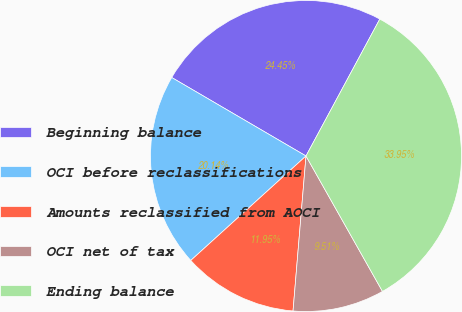<chart> <loc_0><loc_0><loc_500><loc_500><pie_chart><fcel>Beginning balance<fcel>OCI before reclassifications<fcel>Amounts reclassified from AOCI<fcel>OCI net of tax<fcel>Ending balance<nl><fcel>24.45%<fcel>20.14%<fcel>11.95%<fcel>9.51%<fcel>33.95%<nl></chart> 